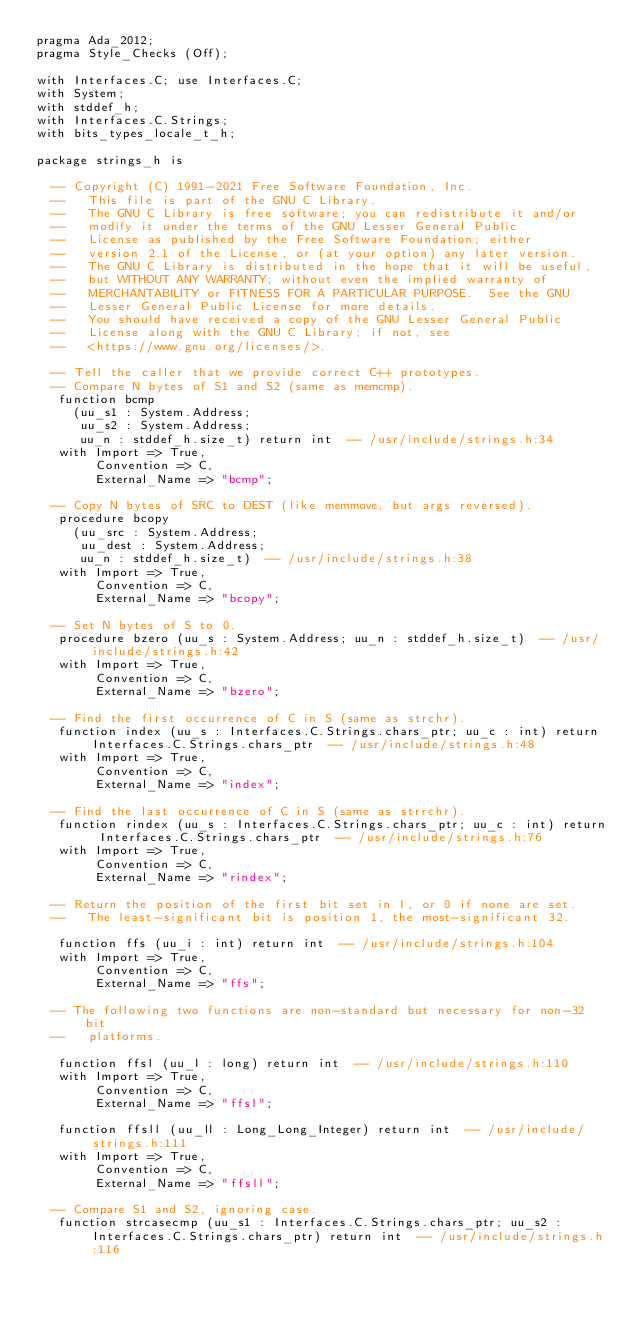Convert code to text. <code><loc_0><loc_0><loc_500><loc_500><_Ada_>pragma Ada_2012;
pragma Style_Checks (Off);

with Interfaces.C; use Interfaces.C;
with System;
with stddef_h;
with Interfaces.C.Strings;
with bits_types_locale_t_h;

package strings_h is

  -- Copyright (C) 1991-2021 Free Software Foundation, Inc.
  --   This file is part of the GNU C Library.
  --   The GNU C Library is free software; you can redistribute it and/or
  --   modify it under the terms of the GNU Lesser General Public
  --   License as published by the Free Software Foundation; either
  --   version 2.1 of the License, or (at your option) any later version.
  --   The GNU C Library is distributed in the hope that it will be useful,
  --   but WITHOUT ANY WARRANTY; without even the implied warranty of
  --   MERCHANTABILITY or FITNESS FOR A PARTICULAR PURPOSE.  See the GNU
  --   Lesser General Public License for more details.
  --   You should have received a copy of the GNU Lesser General Public
  --   License along with the GNU C Library; if not, see
  --   <https://www.gnu.org/licenses/>.   

  -- Tell the caller that we provide correct C++ prototypes.   
  -- Compare N bytes of S1 and S2 (same as memcmp).   
   function bcmp
     (uu_s1 : System.Address;
      uu_s2 : System.Address;
      uu_n : stddef_h.size_t) return int  -- /usr/include/strings.h:34
   with Import => True, 
        Convention => C, 
        External_Name => "bcmp";

  -- Copy N bytes of SRC to DEST (like memmove, but args reversed).   
   procedure bcopy
     (uu_src : System.Address;
      uu_dest : System.Address;
      uu_n : stddef_h.size_t)  -- /usr/include/strings.h:38
   with Import => True, 
        Convention => C, 
        External_Name => "bcopy";

  -- Set N bytes of S to 0.   
   procedure bzero (uu_s : System.Address; uu_n : stddef_h.size_t)  -- /usr/include/strings.h:42
   with Import => True, 
        Convention => C, 
        External_Name => "bzero";

  -- Find the first occurrence of C in S (same as strchr).   
   function index (uu_s : Interfaces.C.Strings.chars_ptr; uu_c : int) return Interfaces.C.Strings.chars_ptr  -- /usr/include/strings.h:48
   with Import => True, 
        Convention => C, 
        External_Name => "index";

  -- Find the last occurrence of C in S (same as strrchr).   
   function rindex (uu_s : Interfaces.C.Strings.chars_ptr; uu_c : int) return Interfaces.C.Strings.chars_ptr  -- /usr/include/strings.h:76
   with Import => True, 
        Convention => C, 
        External_Name => "rindex";

  -- Return the position of the first bit set in I, or 0 if none are set.
  --   The least-significant bit is position 1, the most-significant 32.   

   function ffs (uu_i : int) return int  -- /usr/include/strings.h:104
   with Import => True, 
        Convention => C, 
        External_Name => "ffs";

  -- The following two functions are non-standard but necessary for non-32 bit
  --   platforms.   

   function ffsl (uu_l : long) return int  -- /usr/include/strings.h:110
   with Import => True, 
        Convention => C, 
        External_Name => "ffsl";

   function ffsll (uu_ll : Long_Long_Integer) return int  -- /usr/include/strings.h:111
   with Import => True, 
        Convention => C, 
        External_Name => "ffsll";

  -- Compare S1 and S2, ignoring case.   
   function strcasecmp (uu_s1 : Interfaces.C.Strings.chars_ptr; uu_s2 : Interfaces.C.Strings.chars_ptr) return int  -- /usr/include/strings.h:116</code> 